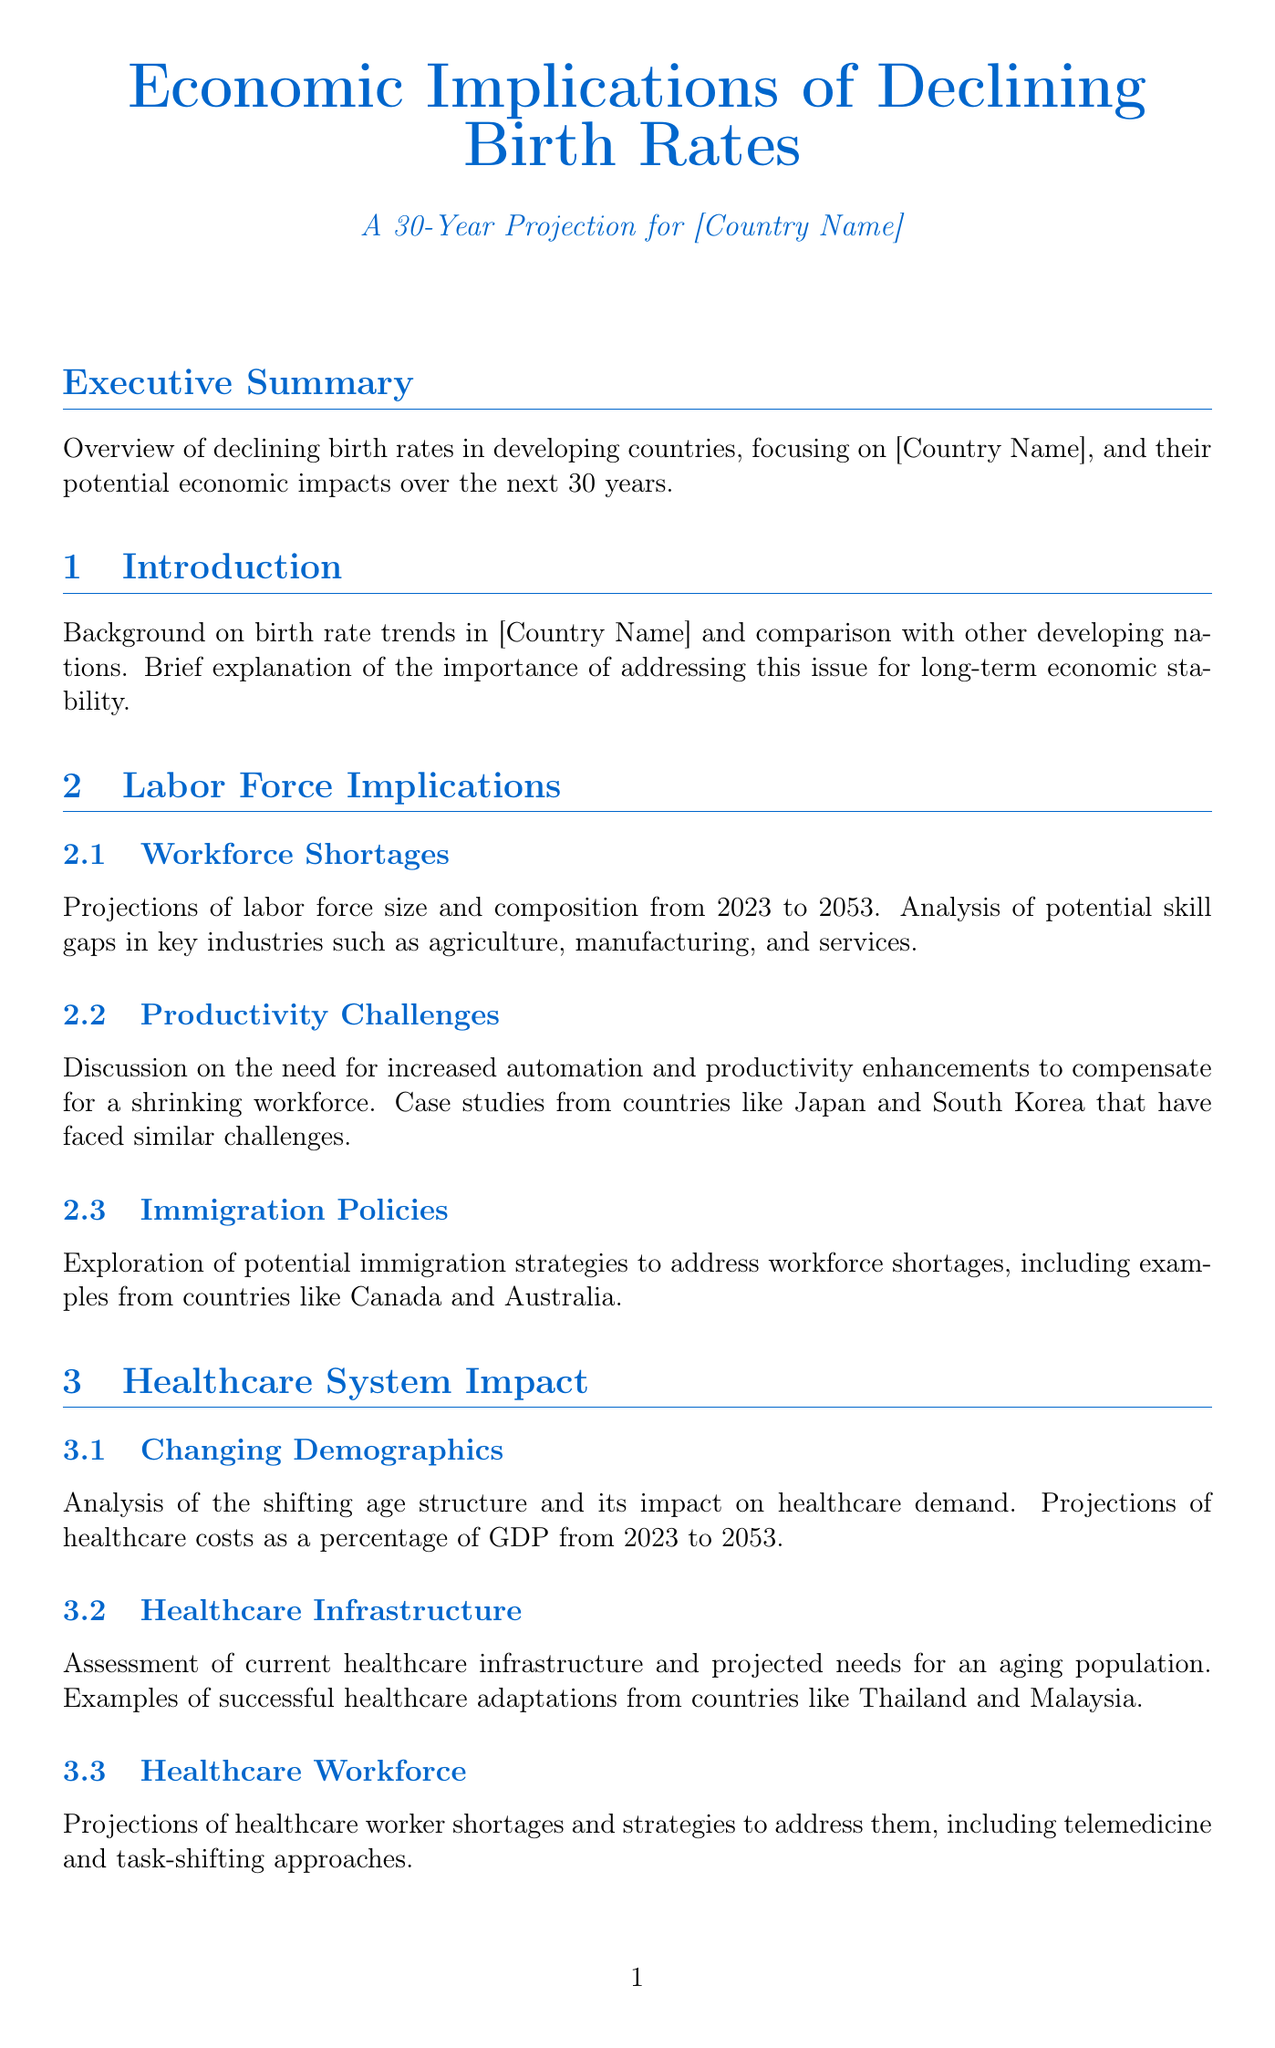what is the main focus of the report? The report focuses on the economic implications of declining birth rates in developing countries, especially in [Country Name].
Answer: economic implications of declining birth rates what years does the projection cover? The projections in the report cover the years from 2023 to 2053.
Answer: 2023 to 2053 which section discusses healthcare costs as a percentage of GDP? The section titled "Changing Demographics" discusses healthcare costs as a percentage of GDP.
Answer: Changing Demographics what is one of the short-term strategies recommended? The report recommends immediate policy actions such as family-friendly policies as a short-term strategy.
Answer: family-friendly policies how many key stakeholders are mentioned in the document? The document mentions five key stakeholders involved in managing and reforming sectors affected by declining birth rates.
Answer: five what case studies are referenced in the report regarding healthcare system adaptations? Countries like Thailand and Malaysia are cited as examples of successful healthcare adaptations in the report.
Answer: Thailand and Malaysia what is the title of Appendix B? The title of Appendix B is "Economic Modeling Methodology."
Answer: Economic Modeling Methodology which ministry is responsible for labor force policies? The Ministry of Labor and Employment is responsible for labor force policies.
Answer: Ministry of Labor and Employment what are the long-term strategies described in the report? The long-term strategies include proposals for fundamental shifts in economic structure and social policies.
Answer: fundamental shifts in economic structure and social policies 